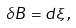<formula> <loc_0><loc_0><loc_500><loc_500>\delta B = d \xi \, ,</formula> 